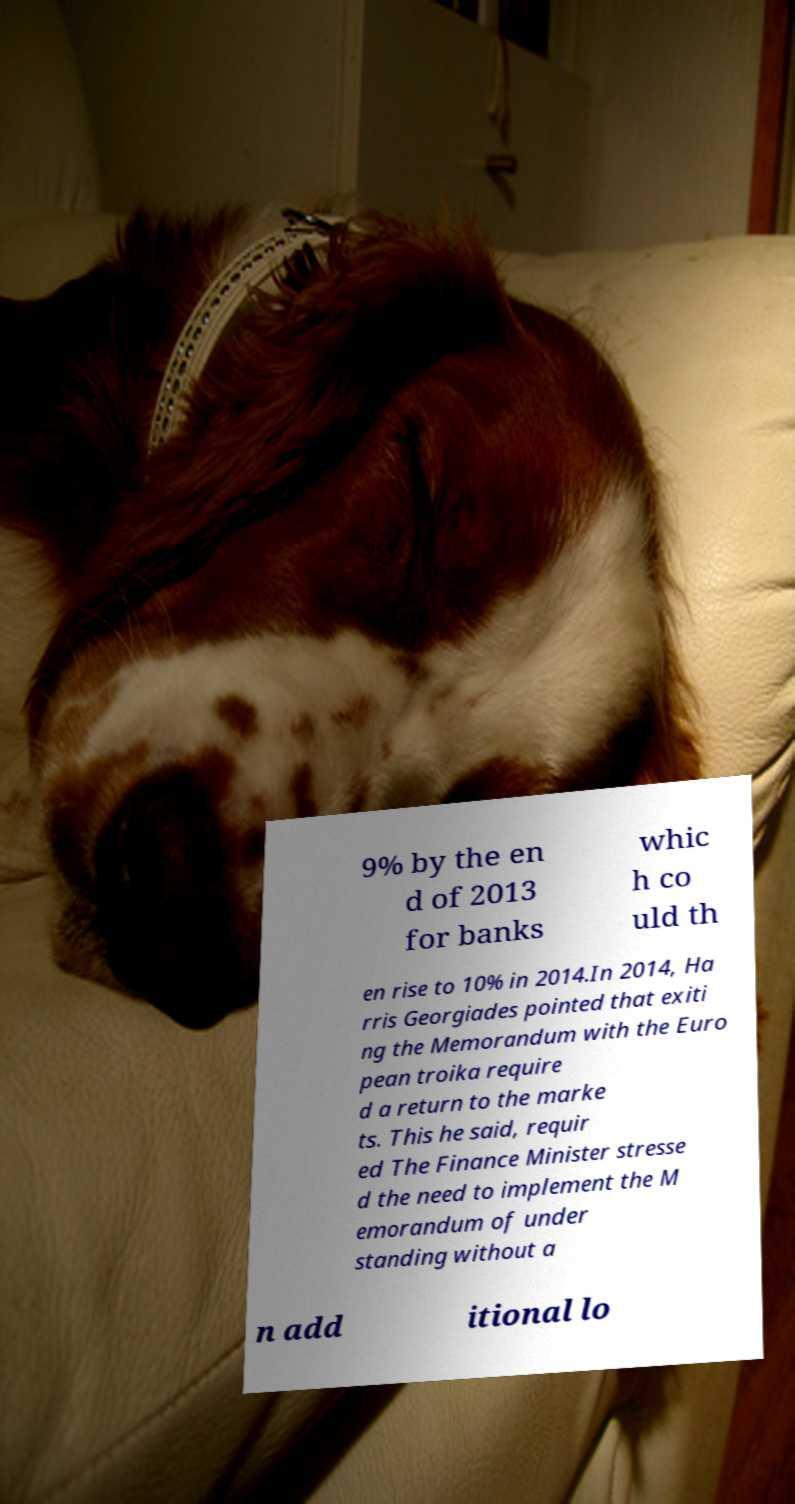I need the written content from this picture converted into text. Can you do that? 9% by the en d of 2013 for banks whic h co uld th en rise to 10% in 2014.In 2014, Ha rris Georgiades pointed that exiti ng the Memorandum with the Euro pean troika require d a return to the marke ts. This he said, requir ed The Finance Minister stresse d the need to implement the M emorandum of under standing without a n add itional lo 